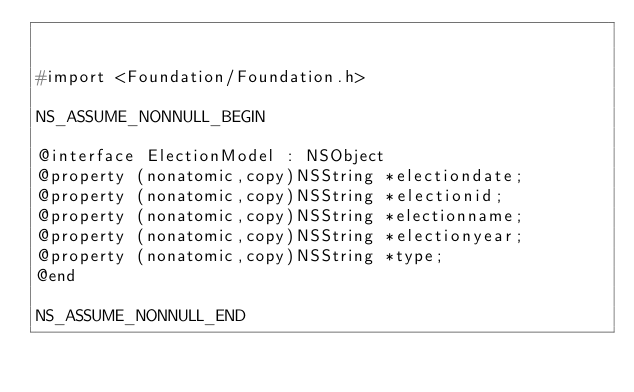Convert code to text. <code><loc_0><loc_0><loc_500><loc_500><_C_>

#import <Foundation/Foundation.h>

NS_ASSUME_NONNULL_BEGIN

@interface ElectionModel : NSObject
@property (nonatomic,copy)NSString *electiondate;
@property (nonatomic,copy)NSString *electionid;
@property (nonatomic,copy)NSString *electionname;
@property (nonatomic,copy)NSString *electionyear;
@property (nonatomic,copy)NSString *type;
@end

NS_ASSUME_NONNULL_END
</code> 